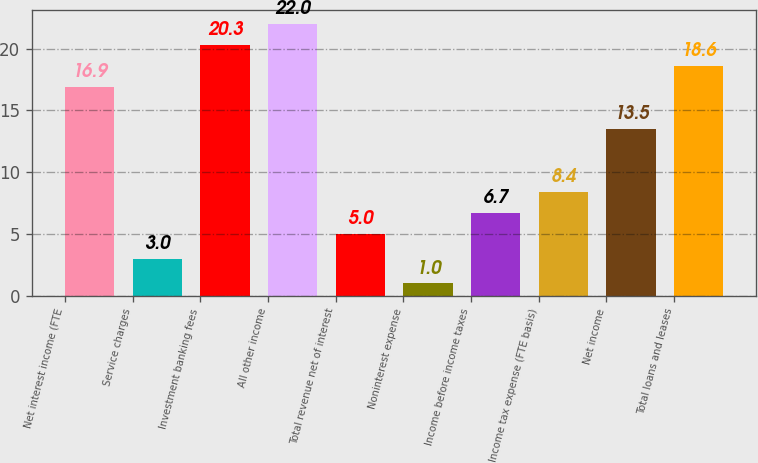Convert chart to OTSL. <chart><loc_0><loc_0><loc_500><loc_500><bar_chart><fcel>Net interest income (FTE<fcel>Service charges<fcel>Investment banking fees<fcel>All other income<fcel>Total revenue net of interest<fcel>Noninterest expense<fcel>Income before income taxes<fcel>Income tax expense (FTE basis)<fcel>Net income<fcel>Total loans and leases<nl><fcel>16.9<fcel>3<fcel>20.3<fcel>22<fcel>5<fcel>1<fcel>6.7<fcel>8.4<fcel>13.5<fcel>18.6<nl></chart> 